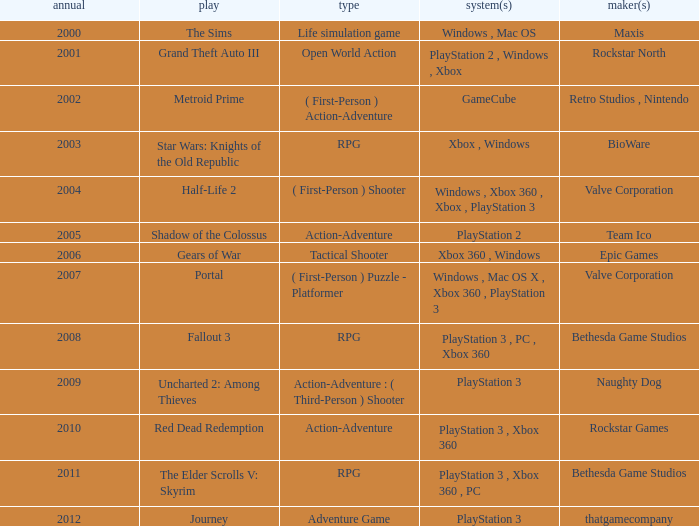Give me the full table as a dictionary. {'header': ['annual', 'play', 'type', 'system(s)', 'maker(s)'], 'rows': [['2000', 'The Sims', 'Life simulation game', 'Windows , Mac OS', 'Maxis'], ['2001', 'Grand Theft Auto III', 'Open World Action', 'PlayStation 2 , Windows , Xbox', 'Rockstar North'], ['2002', 'Metroid Prime', '( First-Person ) Action-Adventure', 'GameCube', 'Retro Studios , Nintendo'], ['2003', 'Star Wars: Knights of the Old Republic', 'RPG', 'Xbox , Windows', 'BioWare'], ['2004', 'Half-Life 2', '( First-Person ) Shooter', 'Windows , Xbox 360 , Xbox , PlayStation 3', 'Valve Corporation'], ['2005', 'Shadow of the Colossus', 'Action-Adventure', 'PlayStation 2', 'Team Ico'], ['2006', 'Gears of War', 'Tactical Shooter', 'Xbox 360 , Windows', 'Epic Games'], ['2007', 'Portal', '( First-Person ) Puzzle - Platformer', 'Windows , Mac OS X , Xbox 360 , PlayStation 3', 'Valve Corporation'], ['2008', 'Fallout 3', 'RPG', 'PlayStation 3 , PC , Xbox 360', 'Bethesda Game Studios'], ['2009', 'Uncharted 2: Among Thieves', 'Action-Adventure : ( Third-Person ) Shooter', 'PlayStation 3', 'Naughty Dog'], ['2010', 'Red Dead Redemption', 'Action-Adventure', 'PlayStation 3 , Xbox 360', 'Rockstar Games'], ['2011', 'The Elder Scrolls V: Skyrim', 'RPG', 'PlayStation 3 , Xbox 360 , PC', 'Bethesda Game Studios'], ['2012', 'Journey', 'Adventure Game', 'PlayStation 3', 'thatgamecompany']]} What game was in 2005? Shadow of the Colossus. 